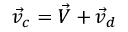<formula> <loc_0><loc_0><loc_500><loc_500>\vec { v } _ { c } = \vec { V } + \vec { v } _ { d }</formula> 